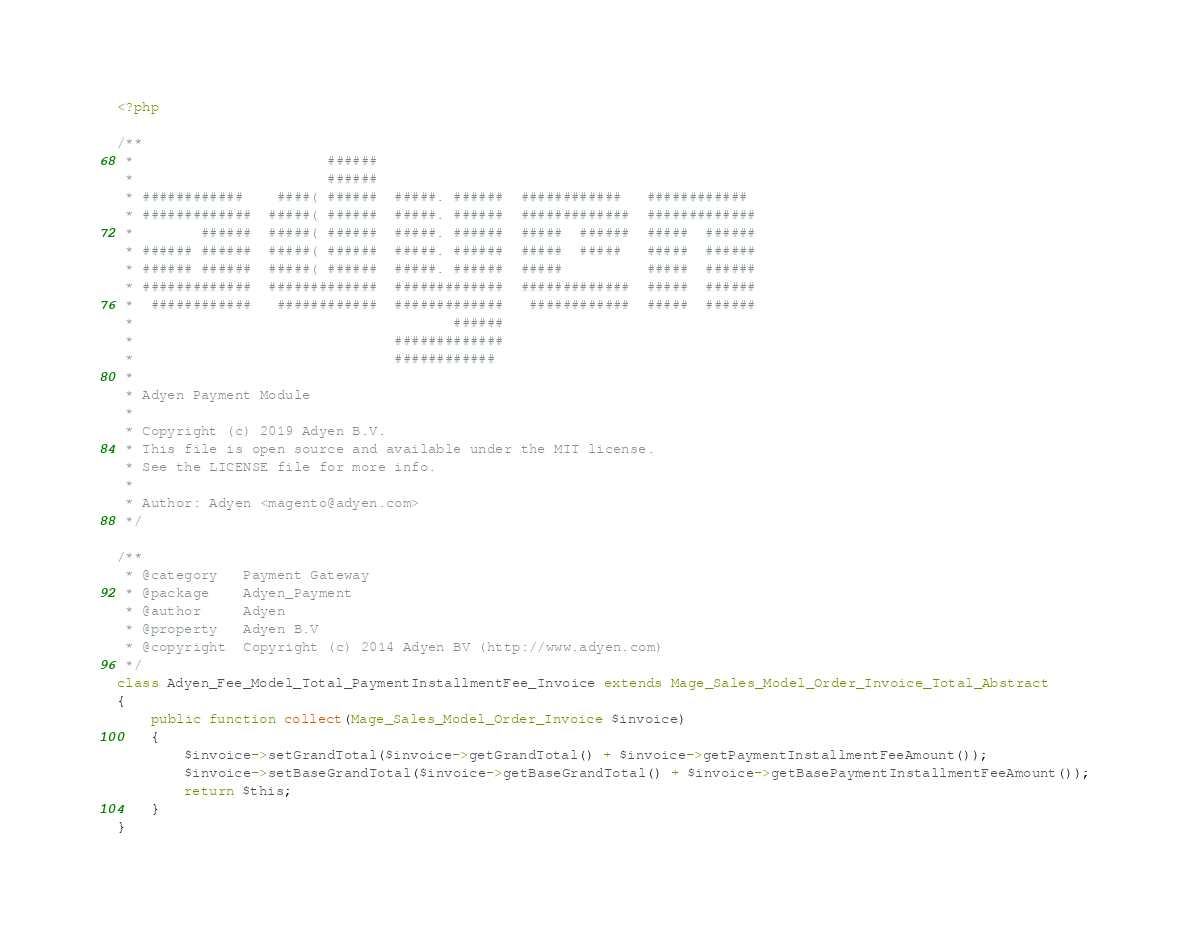<code> <loc_0><loc_0><loc_500><loc_500><_PHP_><?php

/**
 *                       ######
 *                       ######
 * ############    ####( ######  #####. ######  ############   ############
 * #############  #####( ######  #####. ######  #############  #############
 *        ######  #####( ######  #####. ######  #####  ######  #####  ######
 * ###### ######  #####( ######  #####. ######  #####  #####   #####  ######
 * ###### ######  #####( ######  #####. ######  #####          #####  ######
 * #############  #############  #############  #############  #####  ######
 *  ############   ############  #############   ############  #####  ######
 *                                      ######
 *                               #############
 *                               ############
 *
 * Adyen Payment Module
 *
 * Copyright (c) 2019 Adyen B.V.
 * This file is open source and available under the MIT license.
 * See the LICENSE file for more info.
 *
 * Author: Adyen <magento@adyen.com>
 */

/**
 * @category   Payment Gateway
 * @package    Adyen_Payment
 * @author     Adyen
 * @property   Adyen B.V
 * @copyright  Copyright (c) 2014 Adyen BV (http://www.adyen.com)
 */
class Adyen_Fee_Model_Total_PaymentInstallmentFee_Invoice extends Mage_Sales_Model_Order_Invoice_Total_Abstract
{
    public function collect(Mage_Sales_Model_Order_Invoice $invoice)
    {
        $invoice->setGrandTotal($invoice->getGrandTotal() + $invoice->getPaymentInstallmentFeeAmount());
        $invoice->setBaseGrandTotal($invoice->getBaseGrandTotal() + $invoice->getBasePaymentInstallmentFeeAmount());
        return $this;
    }
}</code> 